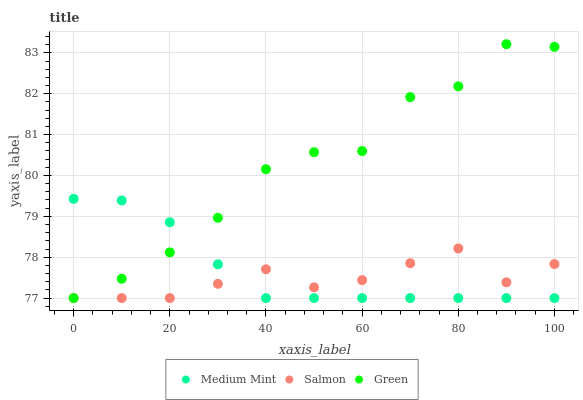Does Salmon have the minimum area under the curve?
Answer yes or no. Yes. Does Green have the maximum area under the curve?
Answer yes or no. Yes. Does Green have the minimum area under the curve?
Answer yes or no. No. Does Salmon have the maximum area under the curve?
Answer yes or no. No. Is Medium Mint the smoothest?
Answer yes or no. Yes. Is Green the roughest?
Answer yes or no. Yes. Is Salmon the smoothest?
Answer yes or no. No. Is Salmon the roughest?
Answer yes or no. No. Does Medium Mint have the lowest value?
Answer yes or no. Yes. Does Green have the highest value?
Answer yes or no. Yes. Does Salmon have the highest value?
Answer yes or no. No. Does Medium Mint intersect Salmon?
Answer yes or no. Yes. Is Medium Mint less than Salmon?
Answer yes or no. No. Is Medium Mint greater than Salmon?
Answer yes or no. No. 